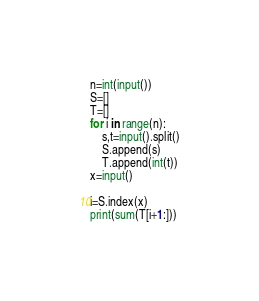Convert code to text. <code><loc_0><loc_0><loc_500><loc_500><_Python_>n=int(input())
S=[]
T=[]
for i in range(n):
	s,t=input().split()
	S.append(s)
	T.append(int(t))
x=input()

i=S.index(x)
print(sum(T[i+1:]))</code> 